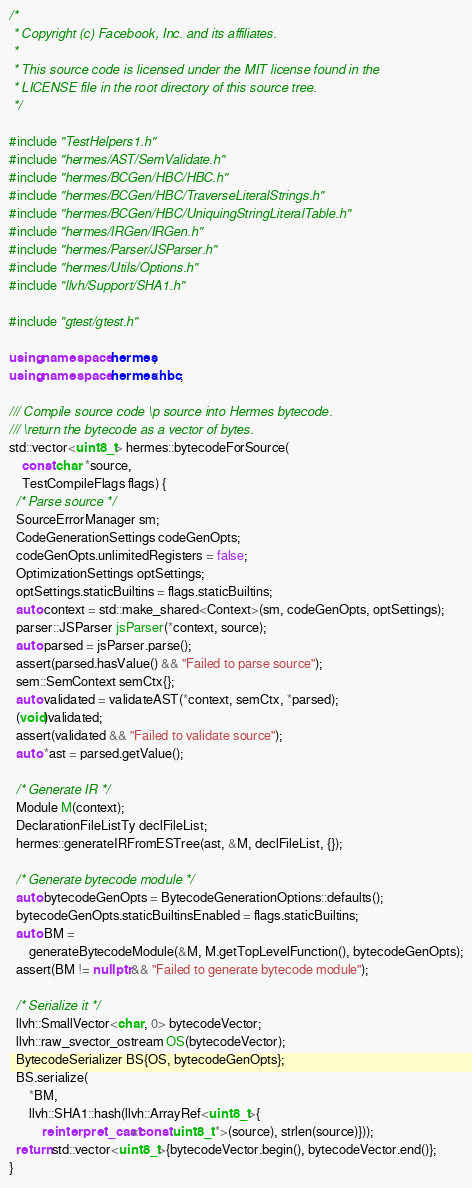Convert code to text. <code><loc_0><loc_0><loc_500><loc_500><_C++_>/*
 * Copyright (c) Facebook, Inc. and its affiliates.
 *
 * This source code is licensed under the MIT license found in the
 * LICENSE file in the root directory of this source tree.
 */

#include "TestHelpers1.h"
#include "hermes/AST/SemValidate.h"
#include "hermes/BCGen/HBC/HBC.h"
#include "hermes/BCGen/HBC/TraverseLiteralStrings.h"
#include "hermes/BCGen/HBC/UniquingStringLiteralTable.h"
#include "hermes/IRGen/IRGen.h"
#include "hermes/Parser/JSParser.h"
#include "hermes/Utils/Options.h"
#include "llvh/Support/SHA1.h"

#include "gtest/gtest.h"

using namespace hermes;
using namespace hermes::hbc;

/// Compile source code \p source into Hermes bytecode.
/// \return the bytecode as a vector of bytes.
std::vector<uint8_t> hermes::bytecodeForSource(
    const char *source,
    TestCompileFlags flags) {
  /* Parse source */
  SourceErrorManager sm;
  CodeGenerationSettings codeGenOpts;
  codeGenOpts.unlimitedRegisters = false;
  OptimizationSettings optSettings;
  optSettings.staticBuiltins = flags.staticBuiltins;
  auto context = std::make_shared<Context>(sm, codeGenOpts, optSettings);
  parser::JSParser jsParser(*context, source);
  auto parsed = jsParser.parse();
  assert(parsed.hasValue() && "Failed to parse source");
  sem::SemContext semCtx{};
  auto validated = validateAST(*context, semCtx, *parsed);
  (void)validated;
  assert(validated && "Failed to validate source");
  auto *ast = parsed.getValue();

  /* Generate IR */
  Module M(context);
  DeclarationFileListTy declFileList;
  hermes::generateIRFromESTree(ast, &M, declFileList, {});

  /* Generate bytecode module */
  auto bytecodeGenOpts = BytecodeGenerationOptions::defaults();
  bytecodeGenOpts.staticBuiltinsEnabled = flags.staticBuiltins;
  auto BM =
      generateBytecodeModule(&M, M.getTopLevelFunction(), bytecodeGenOpts);
  assert(BM != nullptr && "Failed to generate bytecode module");

  /* Serialize it */
  llvh::SmallVector<char, 0> bytecodeVector;
  llvh::raw_svector_ostream OS(bytecodeVector);
  BytecodeSerializer BS{OS, bytecodeGenOpts};
  BS.serialize(
      *BM,
      llvh::SHA1::hash(llvh::ArrayRef<uint8_t>{
          reinterpret_cast<const uint8_t *>(source), strlen(source)}));
  return std::vector<uint8_t>{bytecodeVector.begin(), bytecodeVector.end()};
}
</code> 